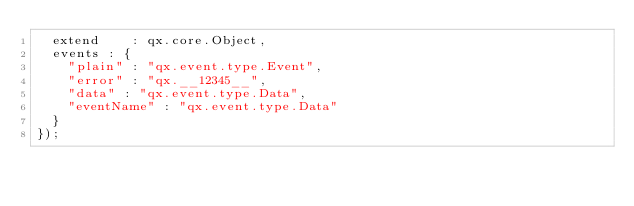Convert code to text. <code><loc_0><loc_0><loc_500><loc_500><_JavaScript_>  extend    : qx.core.Object,
  events : {
    "plain" : "qx.event.type.Event",
    "error" : "qx.__12345__",
    "data" : "qx.event.type.Data",
    "eventName" : "qx.event.type.Data"
  }
});
</code> 